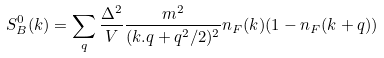<formula> <loc_0><loc_0><loc_500><loc_500>S ^ { 0 } _ { B } ( { k } ) = \sum _ { q } \frac { \Delta ^ { 2 } } { V } \frac { m ^ { 2 } } { ( { k . q } + { q } ^ { 2 } / 2 ) ^ { 2 } } n _ { F } ( { k } ) ( 1 - n _ { F } ( { k } + { q } ) )</formula> 